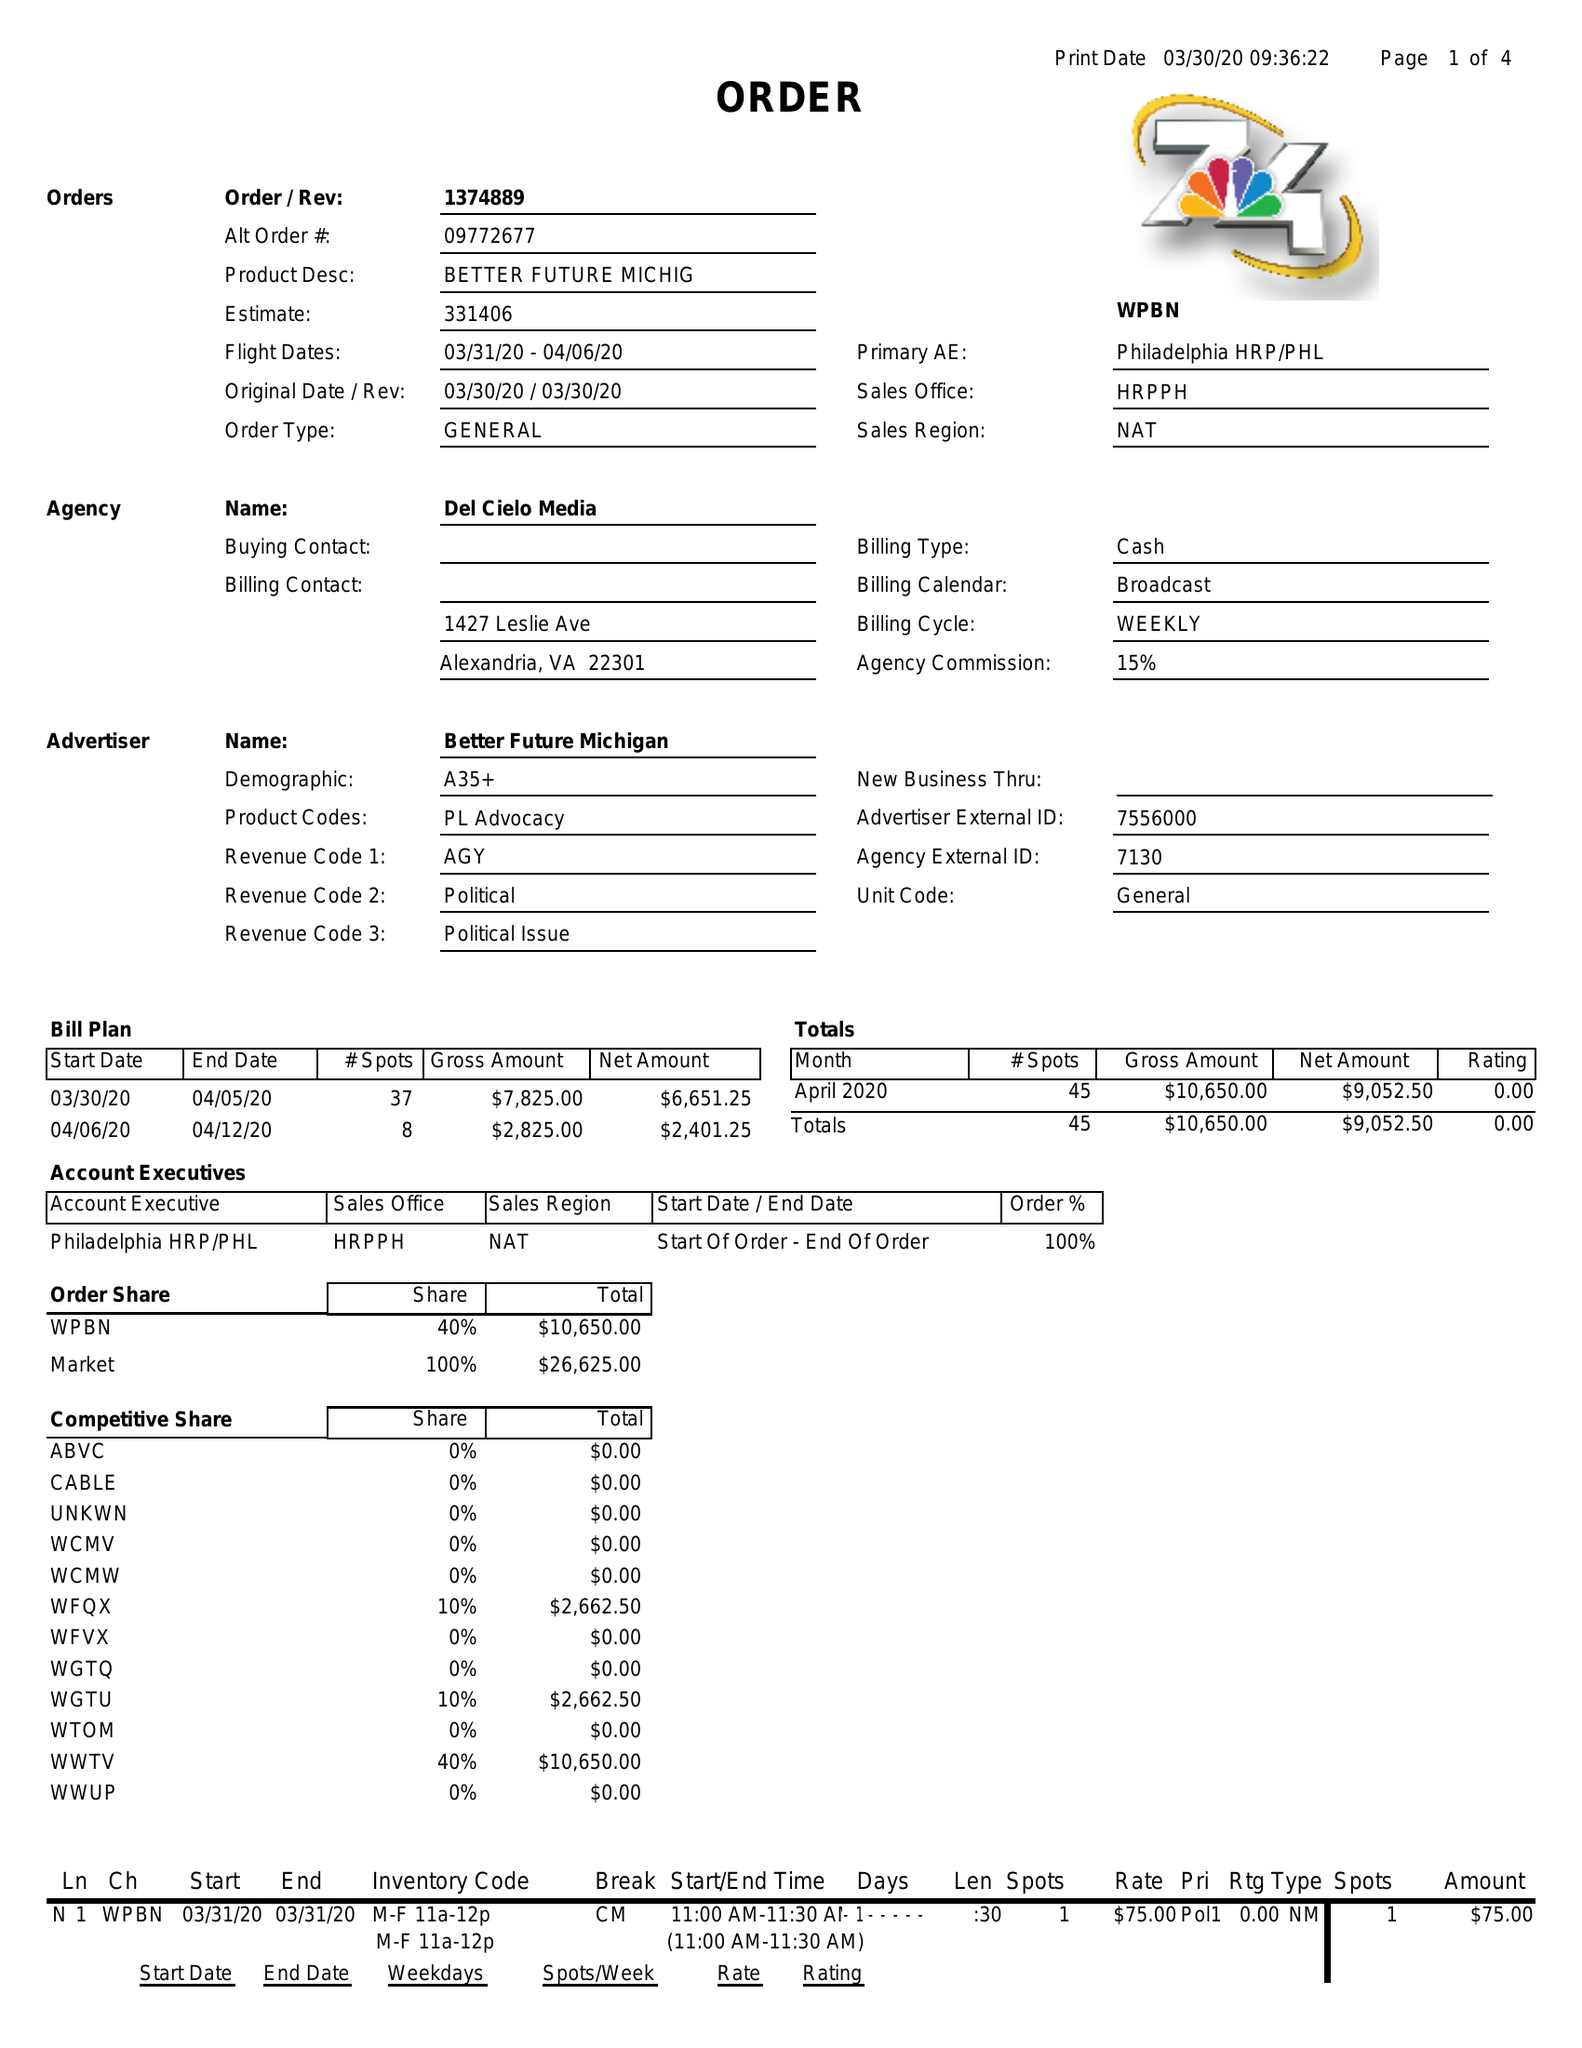What is the value for the flight_to?
Answer the question using a single word or phrase. 04/06/20 